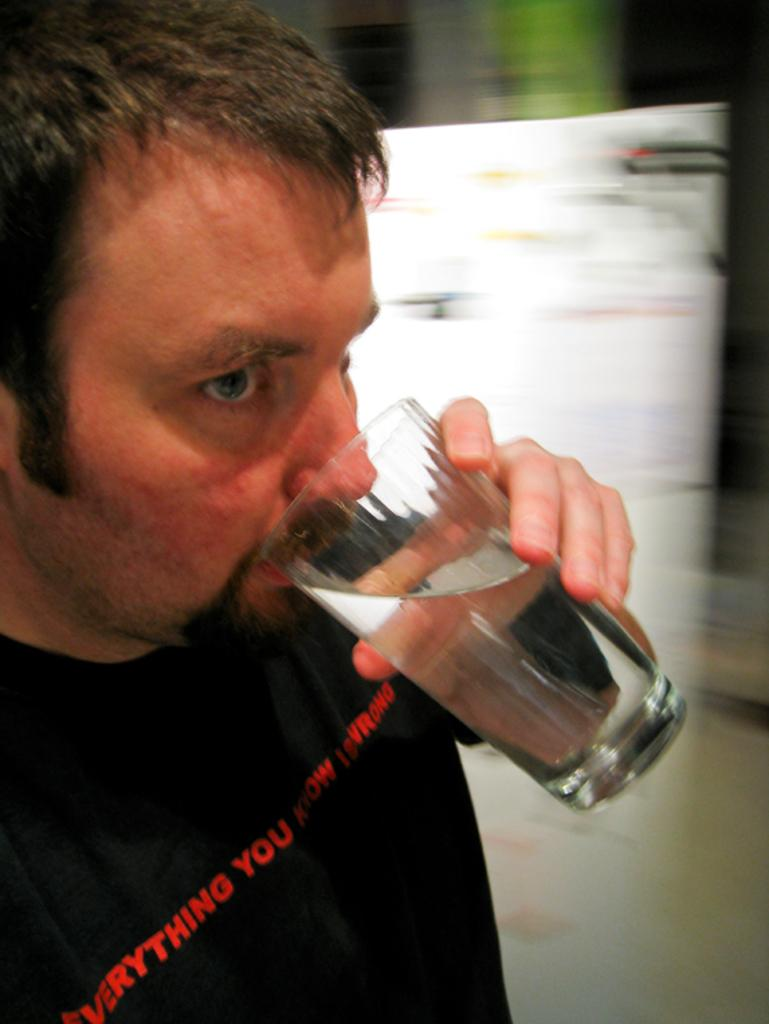What can be seen in the image? There is a person in the image. What is the person holding? The person is holding a glass. What is the person wearing? The person is wearing a black color shirt. How would you describe the background of the image? The background of the image is blurred. What type of pickle is the person using to build a brick wall in the image? There is no pickle or brick wall present in the image, and therefore no such activity can be observed. 